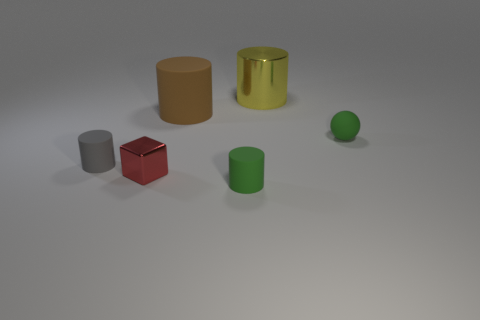Add 4 big purple matte cylinders. How many objects exist? 10 Subtract all cylinders. How many objects are left? 2 Subtract 0 purple spheres. How many objects are left? 6 Subtract all tiny green things. Subtract all big yellow metal things. How many objects are left? 3 Add 5 red things. How many red things are left? 6 Add 2 large yellow shiny cylinders. How many large yellow shiny cylinders exist? 3 